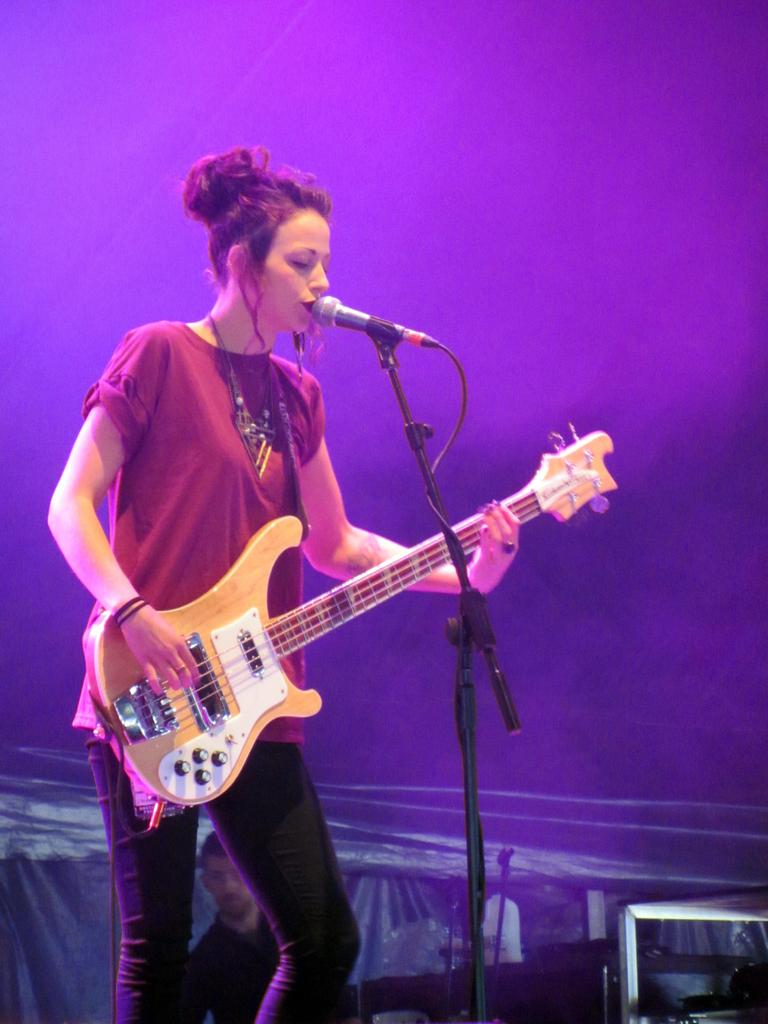Who is the main subject in the image? There is a woman in the image. What is the woman doing in the image? The woman is playing a guitar and singing. How is the woman's voice being amplified in the image? The woman is using a microphone. What type of store can be seen in the background of the image? There is no store visible in the image; it only features the woman playing a guitar, singing, and using a microphone. 